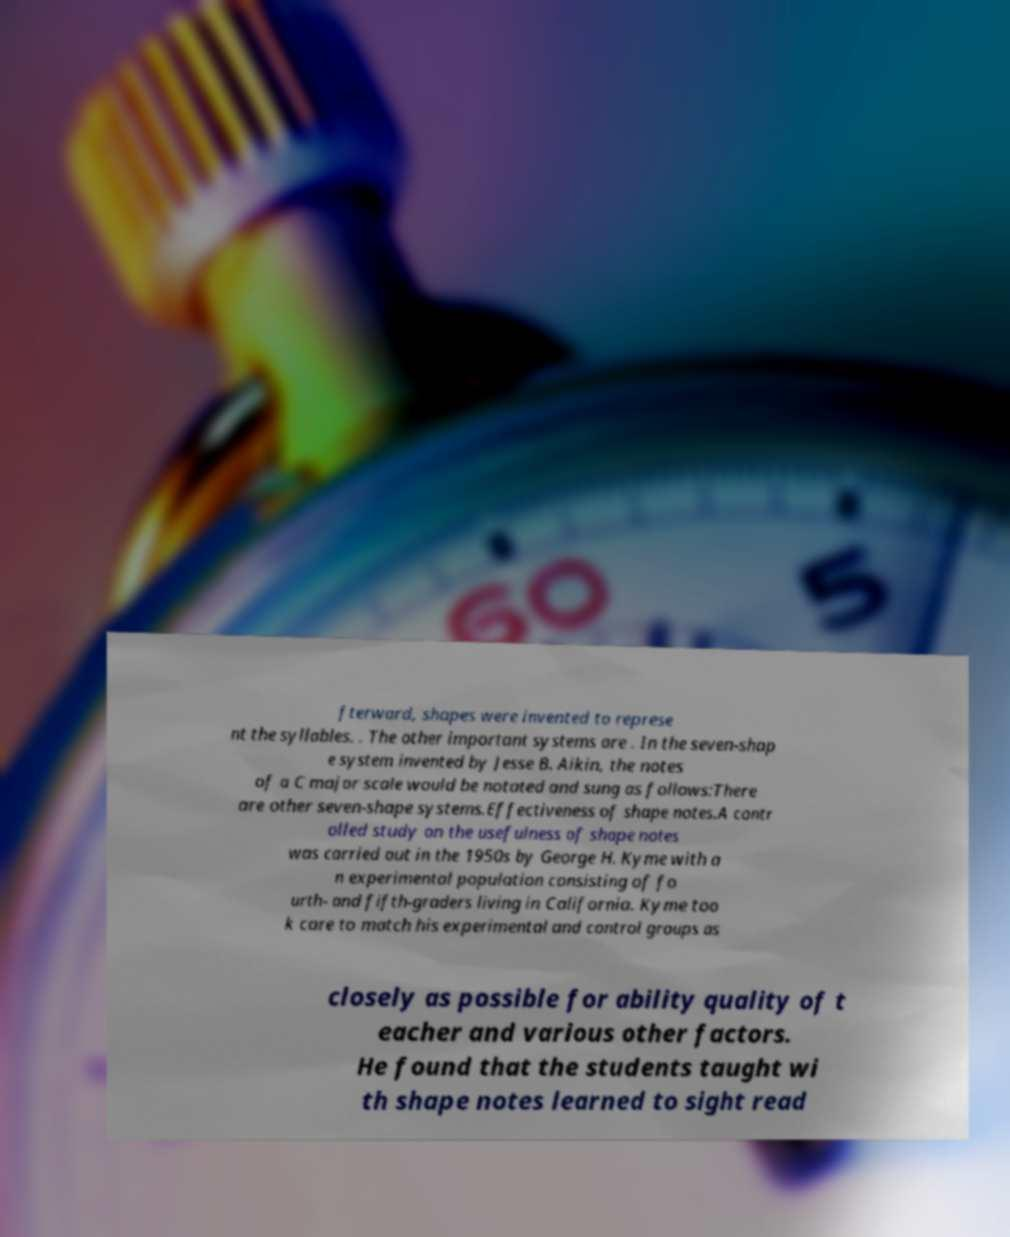Can you read and provide the text displayed in the image?This photo seems to have some interesting text. Can you extract and type it out for me? fterward, shapes were invented to represe nt the syllables. . The other important systems are . In the seven-shap e system invented by Jesse B. Aikin, the notes of a C major scale would be notated and sung as follows:There are other seven-shape systems.Effectiveness of shape notes.A contr olled study on the usefulness of shape notes was carried out in the 1950s by George H. Kyme with a n experimental population consisting of fo urth- and fifth-graders living in California. Kyme too k care to match his experimental and control groups as closely as possible for ability quality of t eacher and various other factors. He found that the students taught wi th shape notes learned to sight read 